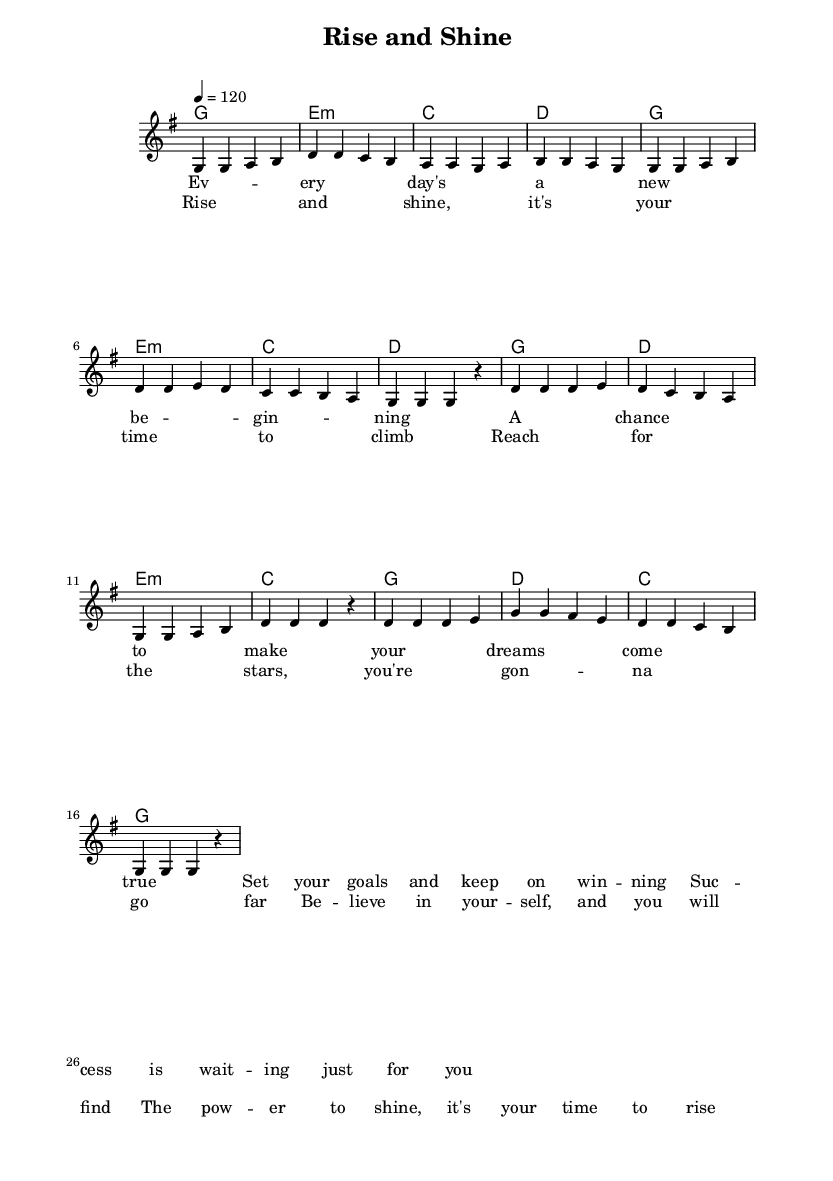What is the key signature of this music? The key signature is G major, which has one sharp (F#). This is determined by the presence of the key signature notation at the beginning of the staff.
Answer: G major What is the time signature of the music? The time signature is 4/4, indicated at the beginning of the score. This means there are four beats in a measure and the quarter note gets the beat.
Answer: 4/4 What is the tempo marking of the music? The tempo marking is 120 beats per minute, shown at the beginning with "4 = 120." This indicates the speed at which the piece should be played.
Answer: 120 How many measures are in the verse section? The verse section consists of 8 measures, as identified by counting the vertical lines separating the measures in the melody part.
Answer: 8 What is the first lyric line of the chorus? The first lyric line of the chorus is "Rise and shine, it's your time to climb." This is taken directly from the lyrics below the melody in the score.
Answer: Rise and shine, it's your time to climb How many chords are used in the chorus? The chorus uses 4 distinct chords: G, D, E minor, and C. This can be verified by examining the chord symbols in the harmony section of the score.
Answer: 4 What theme do the lyrics of this piece largely convey? The lyrics convey themes of ambition and motivation, focused on success and self-belief. This is evident from the encouraging phrases throughout the lyrics.
Answer: Ambition and motivation 